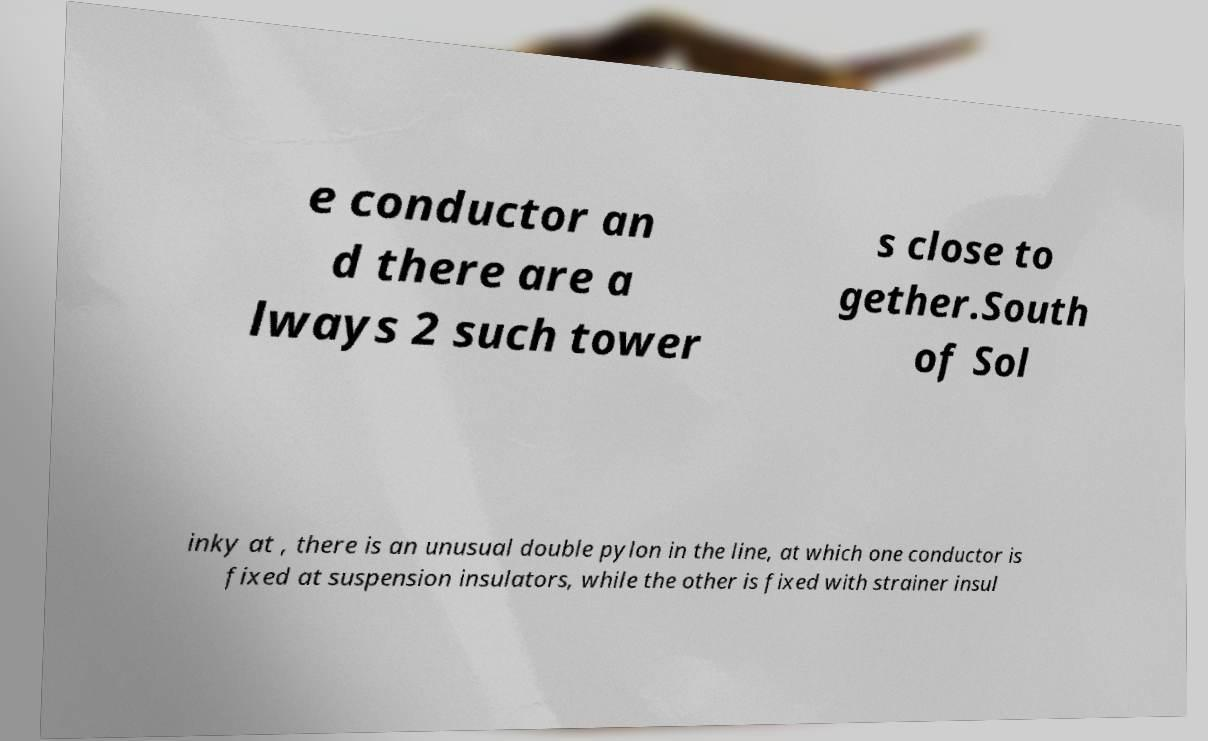Can you read and provide the text displayed in the image?This photo seems to have some interesting text. Can you extract and type it out for me? e conductor an d there are a lways 2 such tower s close to gether.South of Sol inky at , there is an unusual double pylon in the line, at which one conductor is fixed at suspension insulators, while the other is fixed with strainer insul 